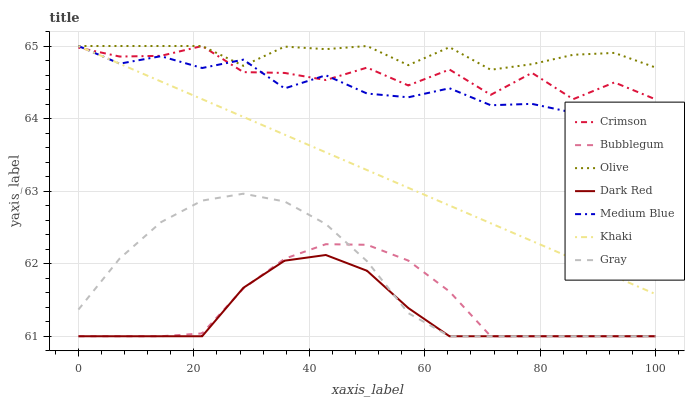Does Dark Red have the minimum area under the curve?
Answer yes or no. Yes. Does Olive have the maximum area under the curve?
Answer yes or no. Yes. Does Khaki have the minimum area under the curve?
Answer yes or no. No. Does Khaki have the maximum area under the curve?
Answer yes or no. No. Is Khaki the smoothest?
Answer yes or no. Yes. Is Crimson the roughest?
Answer yes or no. Yes. Is Dark Red the smoothest?
Answer yes or no. No. Is Dark Red the roughest?
Answer yes or no. No. Does Gray have the lowest value?
Answer yes or no. Yes. Does Khaki have the lowest value?
Answer yes or no. No. Does Crimson have the highest value?
Answer yes or no. Yes. Does Dark Red have the highest value?
Answer yes or no. No. Is Gray less than Olive?
Answer yes or no. Yes. Is Khaki greater than Dark Red?
Answer yes or no. Yes. Does Olive intersect Khaki?
Answer yes or no. Yes. Is Olive less than Khaki?
Answer yes or no. No. Is Olive greater than Khaki?
Answer yes or no. No. Does Gray intersect Olive?
Answer yes or no. No. 